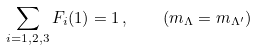<formula> <loc_0><loc_0><loc_500><loc_500>\sum _ { i = 1 , 2 , 3 } F _ { i } ( 1 ) = 1 \, , \quad ( m _ { \Lambda } = m _ { \Lambda ^ { \prime } } )</formula> 